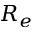<formula> <loc_0><loc_0><loc_500><loc_500>R _ { e }</formula> 